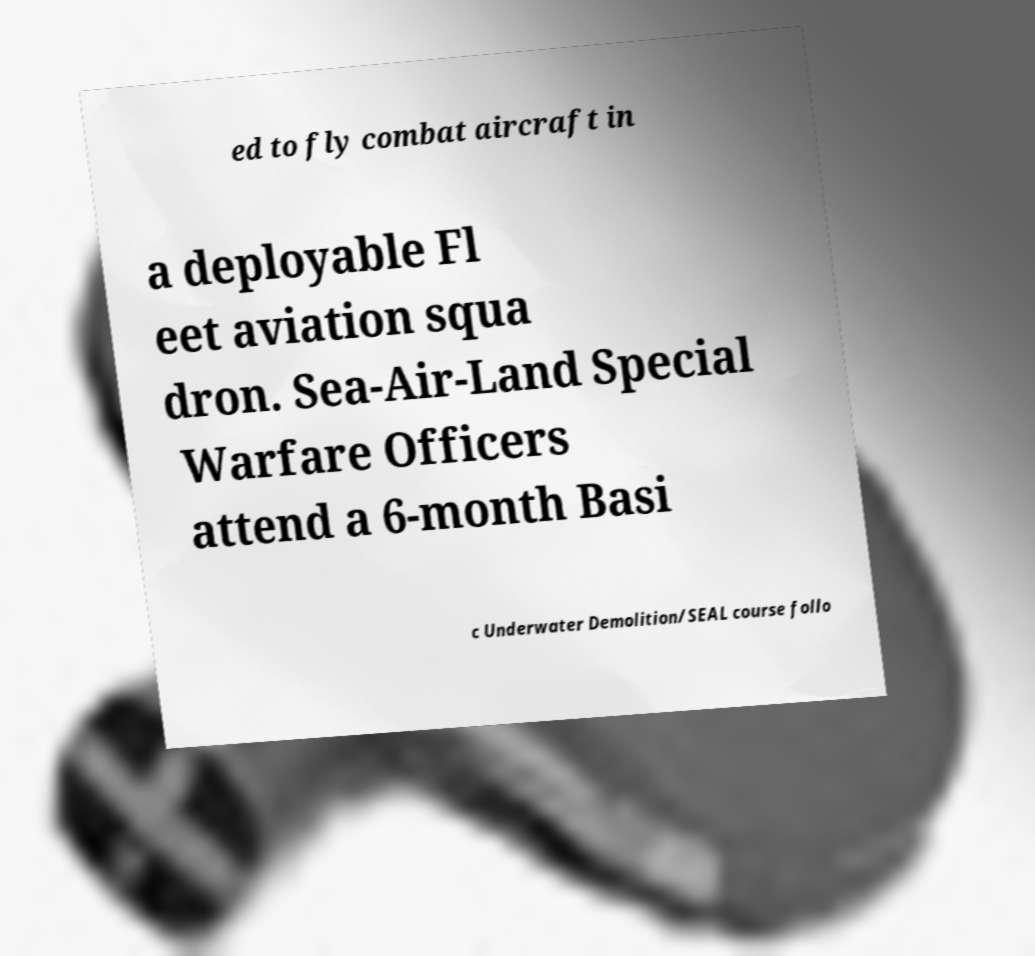Could you assist in decoding the text presented in this image and type it out clearly? ed to fly combat aircraft in a deployable Fl eet aviation squa dron. Sea-Air-Land Special Warfare Officers attend a 6-month Basi c Underwater Demolition/SEAL course follo 